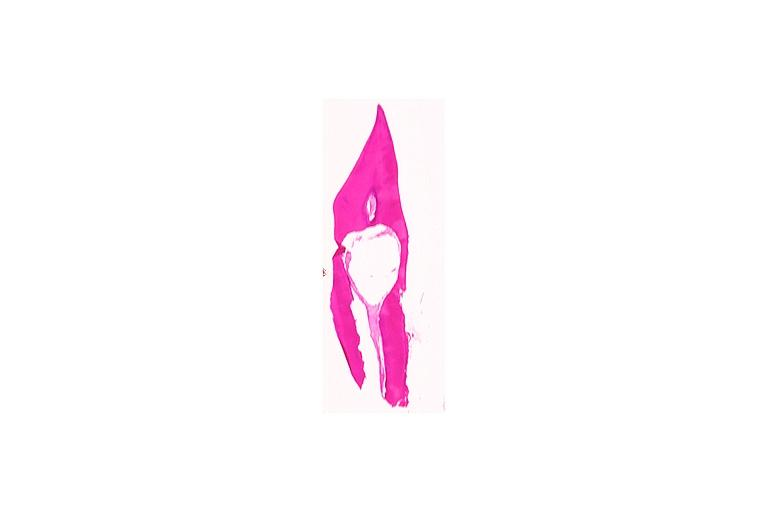does this image show internal resorption?
Answer the question using a single word or phrase. Yes 